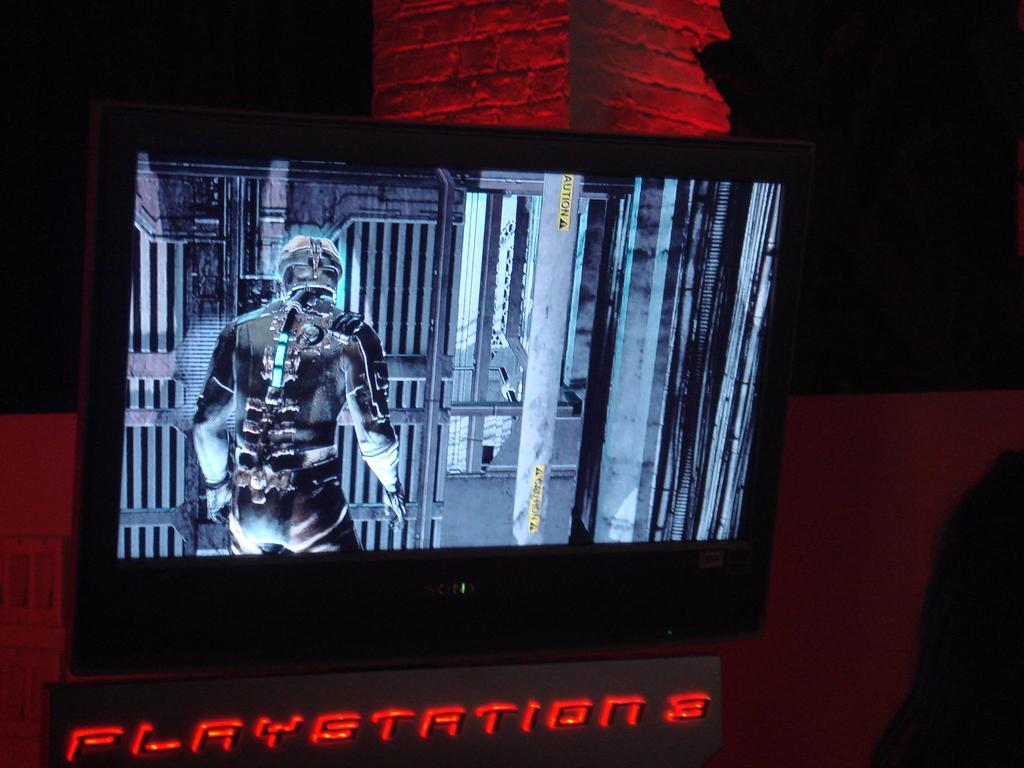<image>
Share a concise interpretation of the image provided. A Playstation 3 video screen shows a figure standing next to a pole with Caution signs posted on it. 